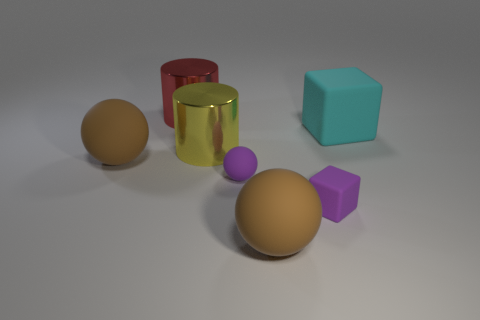Is the material of the brown sphere behind the tiny rubber ball the same as the cyan block?
Give a very brief answer. Yes. The big matte thing that is both right of the red object and in front of the cyan rubber object has what shape?
Provide a succinct answer. Sphere. There is a metallic thing that is on the left side of the yellow thing; are there any tiny purple rubber spheres behind it?
Make the answer very short. No. How many other things are made of the same material as the large red thing?
Your answer should be very brief. 1. Is the shape of the large brown object that is on the left side of the large yellow cylinder the same as the big thing in front of the tiny cube?
Your answer should be very brief. Yes. Is the big cyan object made of the same material as the yellow cylinder?
Ensure brevity in your answer.  No. There is a purple matte thing that is on the right side of the big thing in front of the tiny purple rubber thing that is on the right side of the tiny purple sphere; what is its size?
Ensure brevity in your answer.  Small. How many other things are the same color as the tiny matte sphere?
Your answer should be compact. 1. There is a cyan rubber object that is the same size as the yellow thing; what shape is it?
Your answer should be very brief. Cube. How many small objects are either yellow metal cylinders or matte spheres?
Keep it short and to the point. 1. 